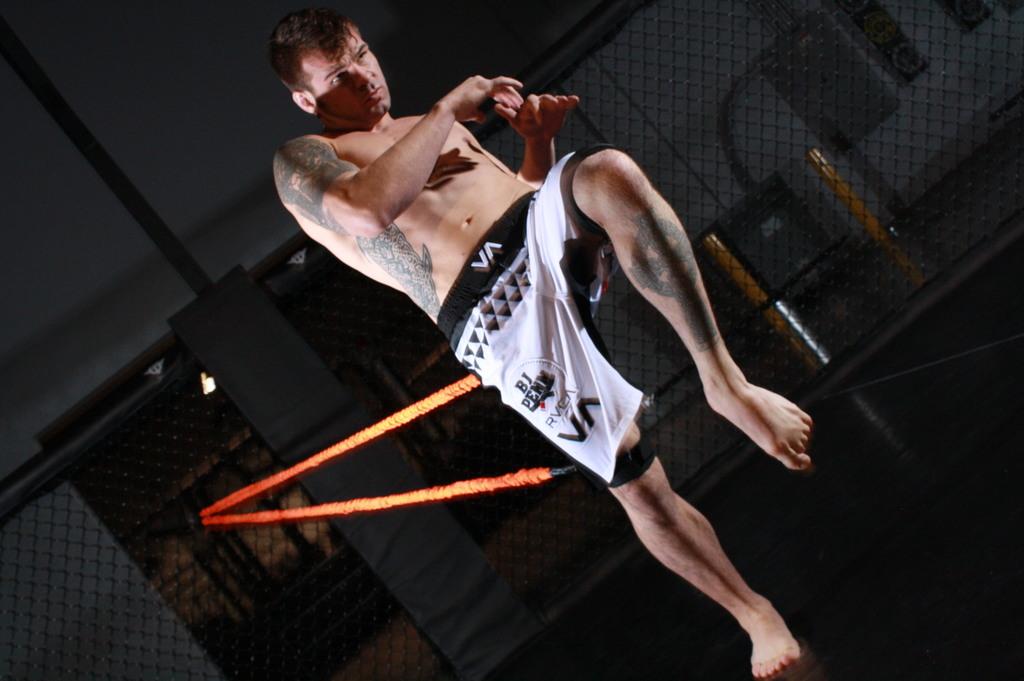What fighters name is on the man's shorts?
Provide a short and direct response. Bj penn. 